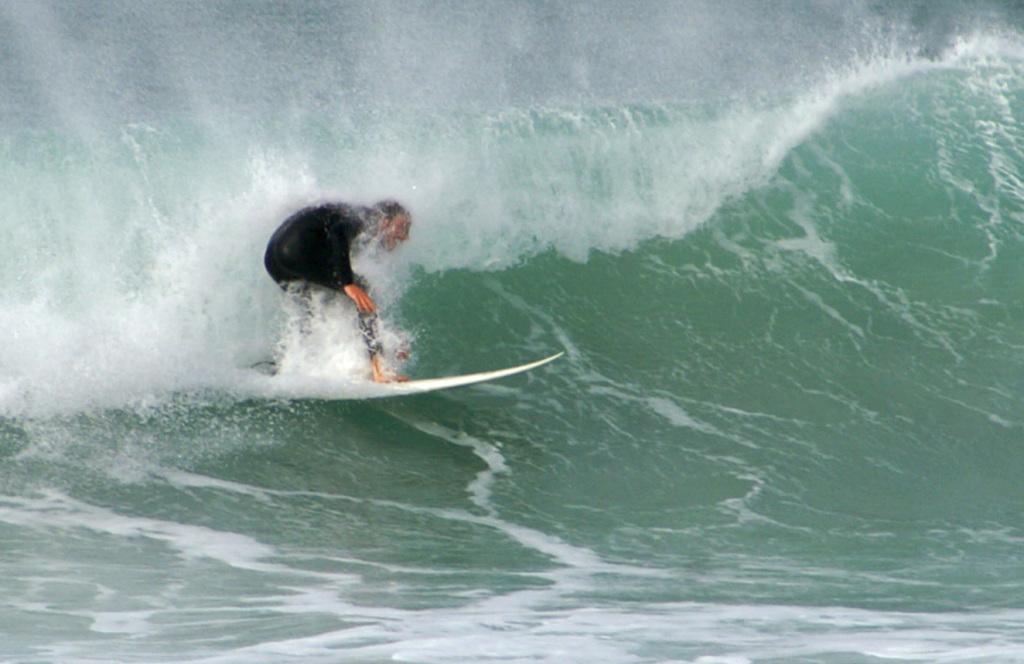Can you describe this image briefly? In this image, I can see a person surfing with a surfboard on the water. I can see the wave. 